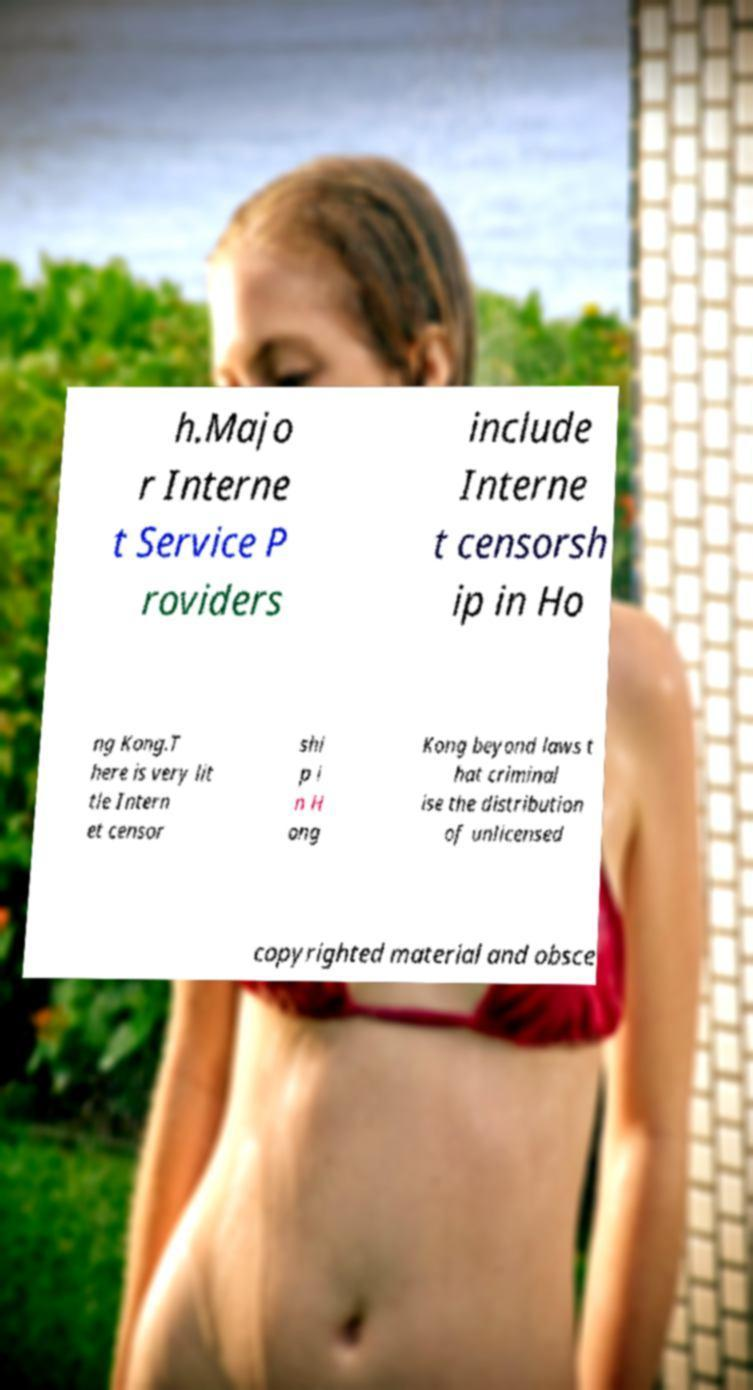Could you extract and type out the text from this image? h.Majo r Interne t Service P roviders include Interne t censorsh ip in Ho ng Kong.T here is very lit tle Intern et censor shi p i n H ong Kong beyond laws t hat criminal ise the distribution of unlicensed copyrighted material and obsce 